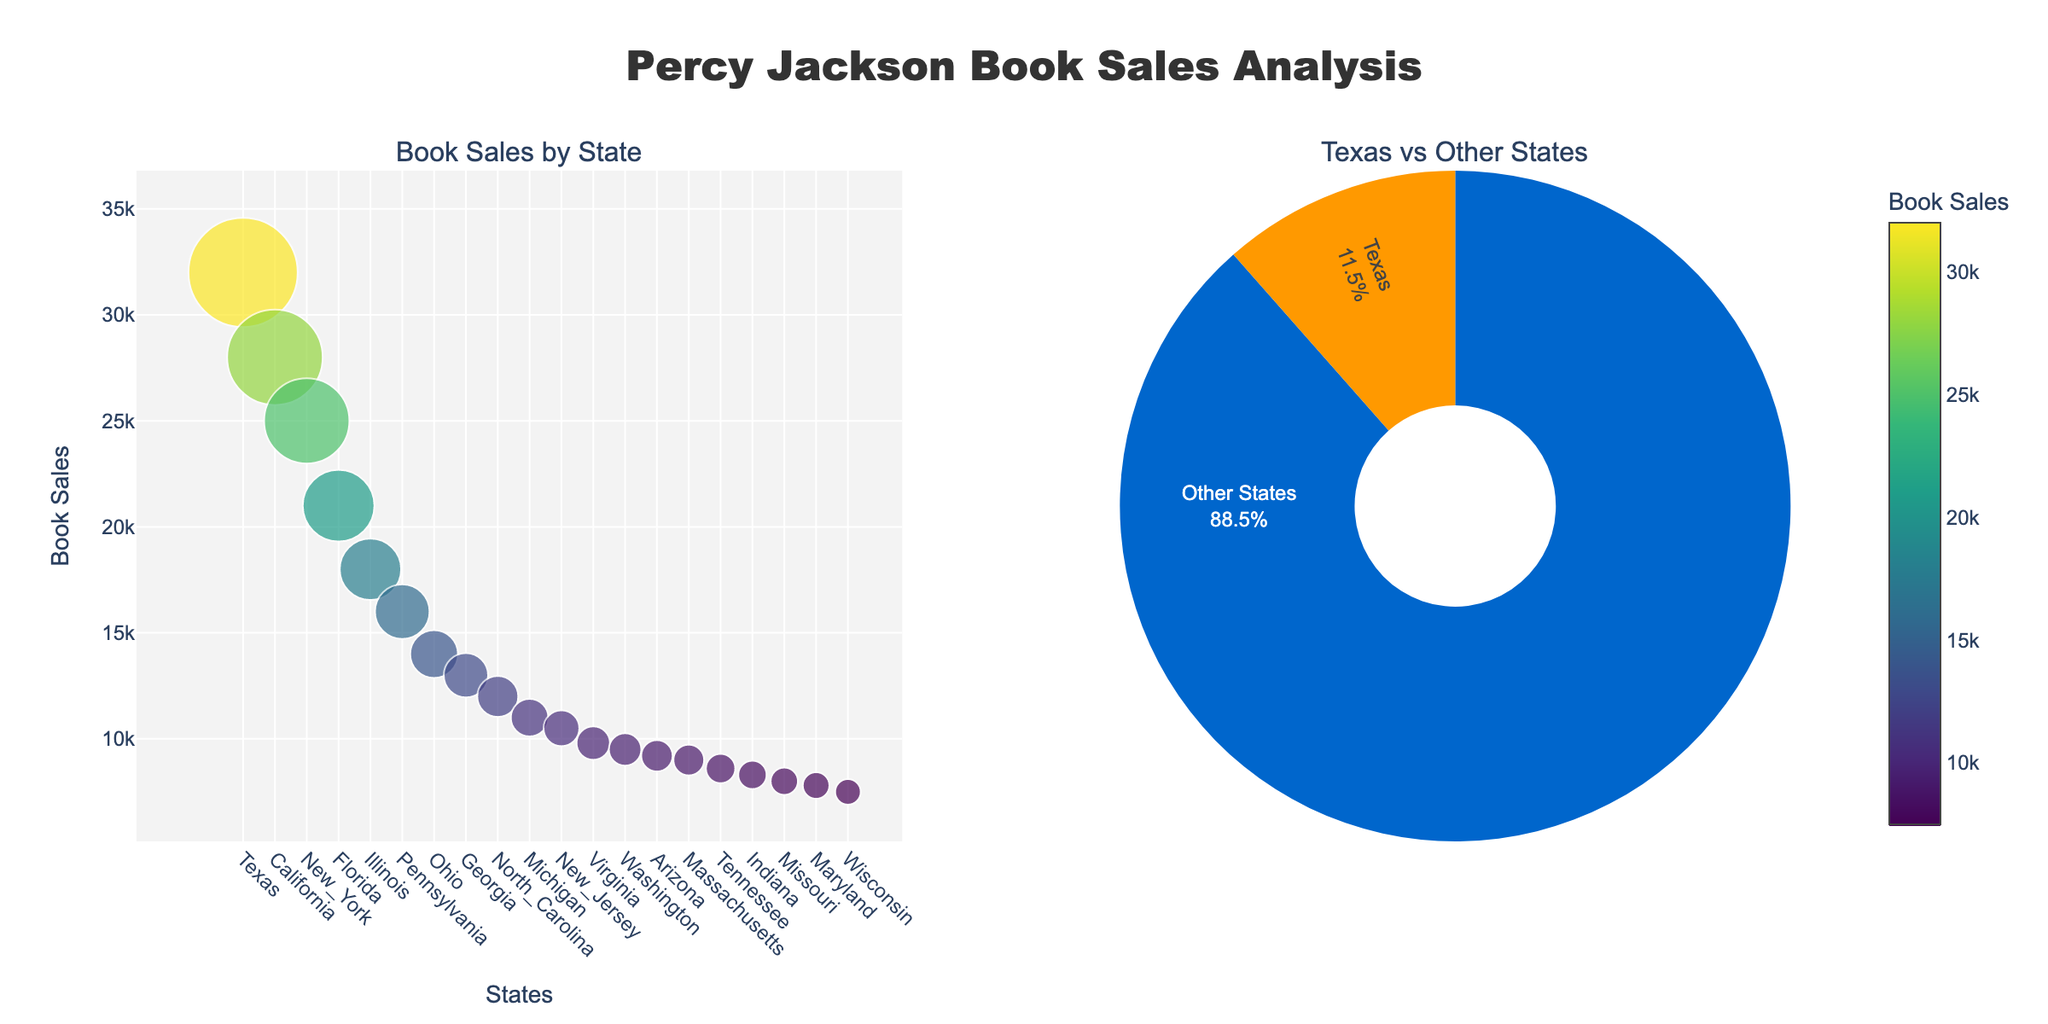What is the title of the plot? The title of the plot is found at the top center of the figure, indicating what the analysis is about.
Answer: Percy Jackson Book Sales Analysis Which state has the highest book sales? The scatter plot on the left shows various states with the size of the markers representing the book sales. The largest marker is labeled "Texas" with the highest value of 32,000 book sales.
Answer: Texas What percentage of book sales come from Texas compared to other states? The pie chart on the right side of the subplot specifies the percentages of book sales. Texas is colored in orange and other states are in blue.
Answer: 39.3% What is the total book sales from states other than Texas? The pie chart divides the entire book sales into Texas and other states. The sales for other states are computed based on the sum of all sales minus the sales from Texas, indicated in the pie chart legend.
Answer: 217,200 How are the states ordered in the scatter plot? Observing the X-axis labels from left to right, states are arranged in descending order of book sales.
Answer: Descending Compare the book sales between California and New York. Which state has higher sales? By looking at the scatter plot, the markers for California (second largest) and New York (third largest) are compared.
Answer: California What is the color range used in the scatter plot to indicate book sales? The colors of the markers in the scatter plot vary from light to dark shades of a color scale (Viridis) depending on the book sales, as shown in the color bar.
Answer: Viridis Estimate the size of the marker for Florida compared to Texas. Markers’ sizes correspond to book sales, where Texas has 32,000 sales and Florida has about 21,000, so Florida’s marker is smaller.
Answer: Florida's marker is smaller Is the proportion of Texas sales greater than the sum of sales from the bottom five states? The bottom five states' sales can be summed up from individual scatter plot data points and compared to the Texas sales value from the pie chart.
Answer: No, Texas sales are greater What is the difference in book sales between Illinois and Michigan? From the scatter plot, we find the sales for Illinois (18,000) and Michigan (11,000). The difference is computed as 18,000 - 11,000.
Answer: 7,000 